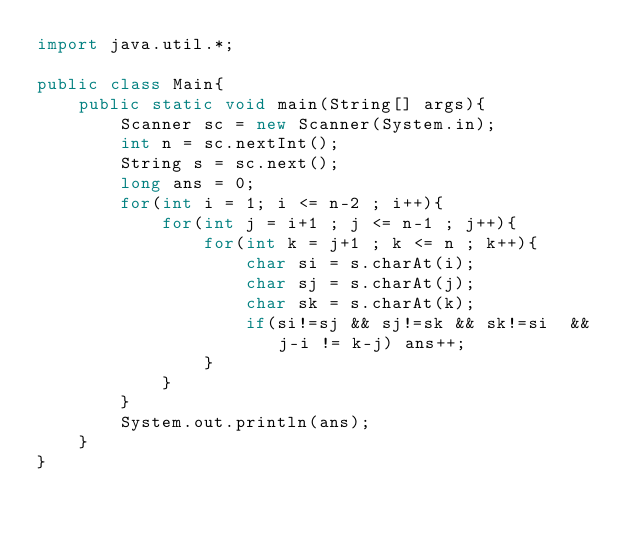Convert code to text. <code><loc_0><loc_0><loc_500><loc_500><_Java_>import java.util.*;

public class Main{
	public static void main(String[] args){
    	Scanner sc = new Scanner(System.in);
      	int n = sc.nextInt();
      	String s = sc.next();
      	long ans = 0;
      	for(int i = 1; i <= n-2 ; i++){
        	for(int j = i+1 ; j <= n-1 ; j++){
              	for(int k = j+1 ; k <= n ; k++){
                  	char si = s.charAt(i);
                  	char sj = s.charAt(j);
                  	char sk = s.charAt(k);
                 	if(si!=sj && sj!=sk && sk!=si  && j-i != k-j) ans++;
                }
            }
        }
      	System.out.println(ans);
    }
}</code> 